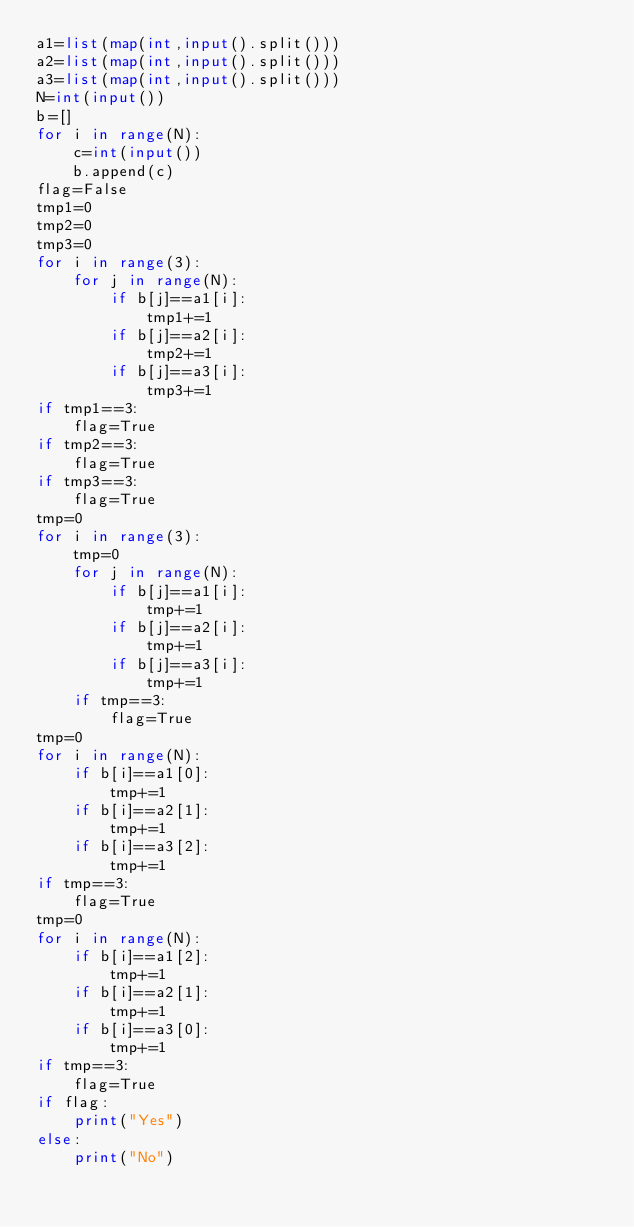Convert code to text. <code><loc_0><loc_0><loc_500><loc_500><_Python_>a1=list(map(int,input().split()))
a2=list(map(int,input().split()))
a3=list(map(int,input().split()))
N=int(input())
b=[]
for i in range(N):
    c=int(input())
    b.append(c)
flag=False
tmp1=0
tmp2=0
tmp3=0
for i in range(3):
    for j in range(N):
        if b[j]==a1[i]:
            tmp1+=1
        if b[j]==a2[i]:
            tmp2+=1
        if b[j]==a3[i]:
            tmp3+=1
if tmp1==3:
    flag=True
if tmp2==3:
    flag=True
if tmp3==3:
    flag=True
tmp=0
for i in range(3):
    tmp=0
    for j in range(N):
        if b[j]==a1[i]:
            tmp+=1
        if b[j]==a2[i]:
            tmp+=1
        if b[j]==a3[i]:
            tmp+=1
    if tmp==3:
        flag=True
tmp=0
for i in range(N):
    if b[i]==a1[0]:
        tmp+=1
    if b[i]==a2[1]:
        tmp+=1
    if b[i]==a3[2]:
        tmp+=1
if tmp==3:
    flag=True
tmp=0
for i in range(N):
    if b[i]==a1[2]:
        tmp+=1
    if b[i]==a2[1]:
        tmp+=1
    if b[i]==a3[0]:
        tmp+=1
if tmp==3:
    flag=True
if flag:
    print("Yes")
else:
    print("No")</code> 